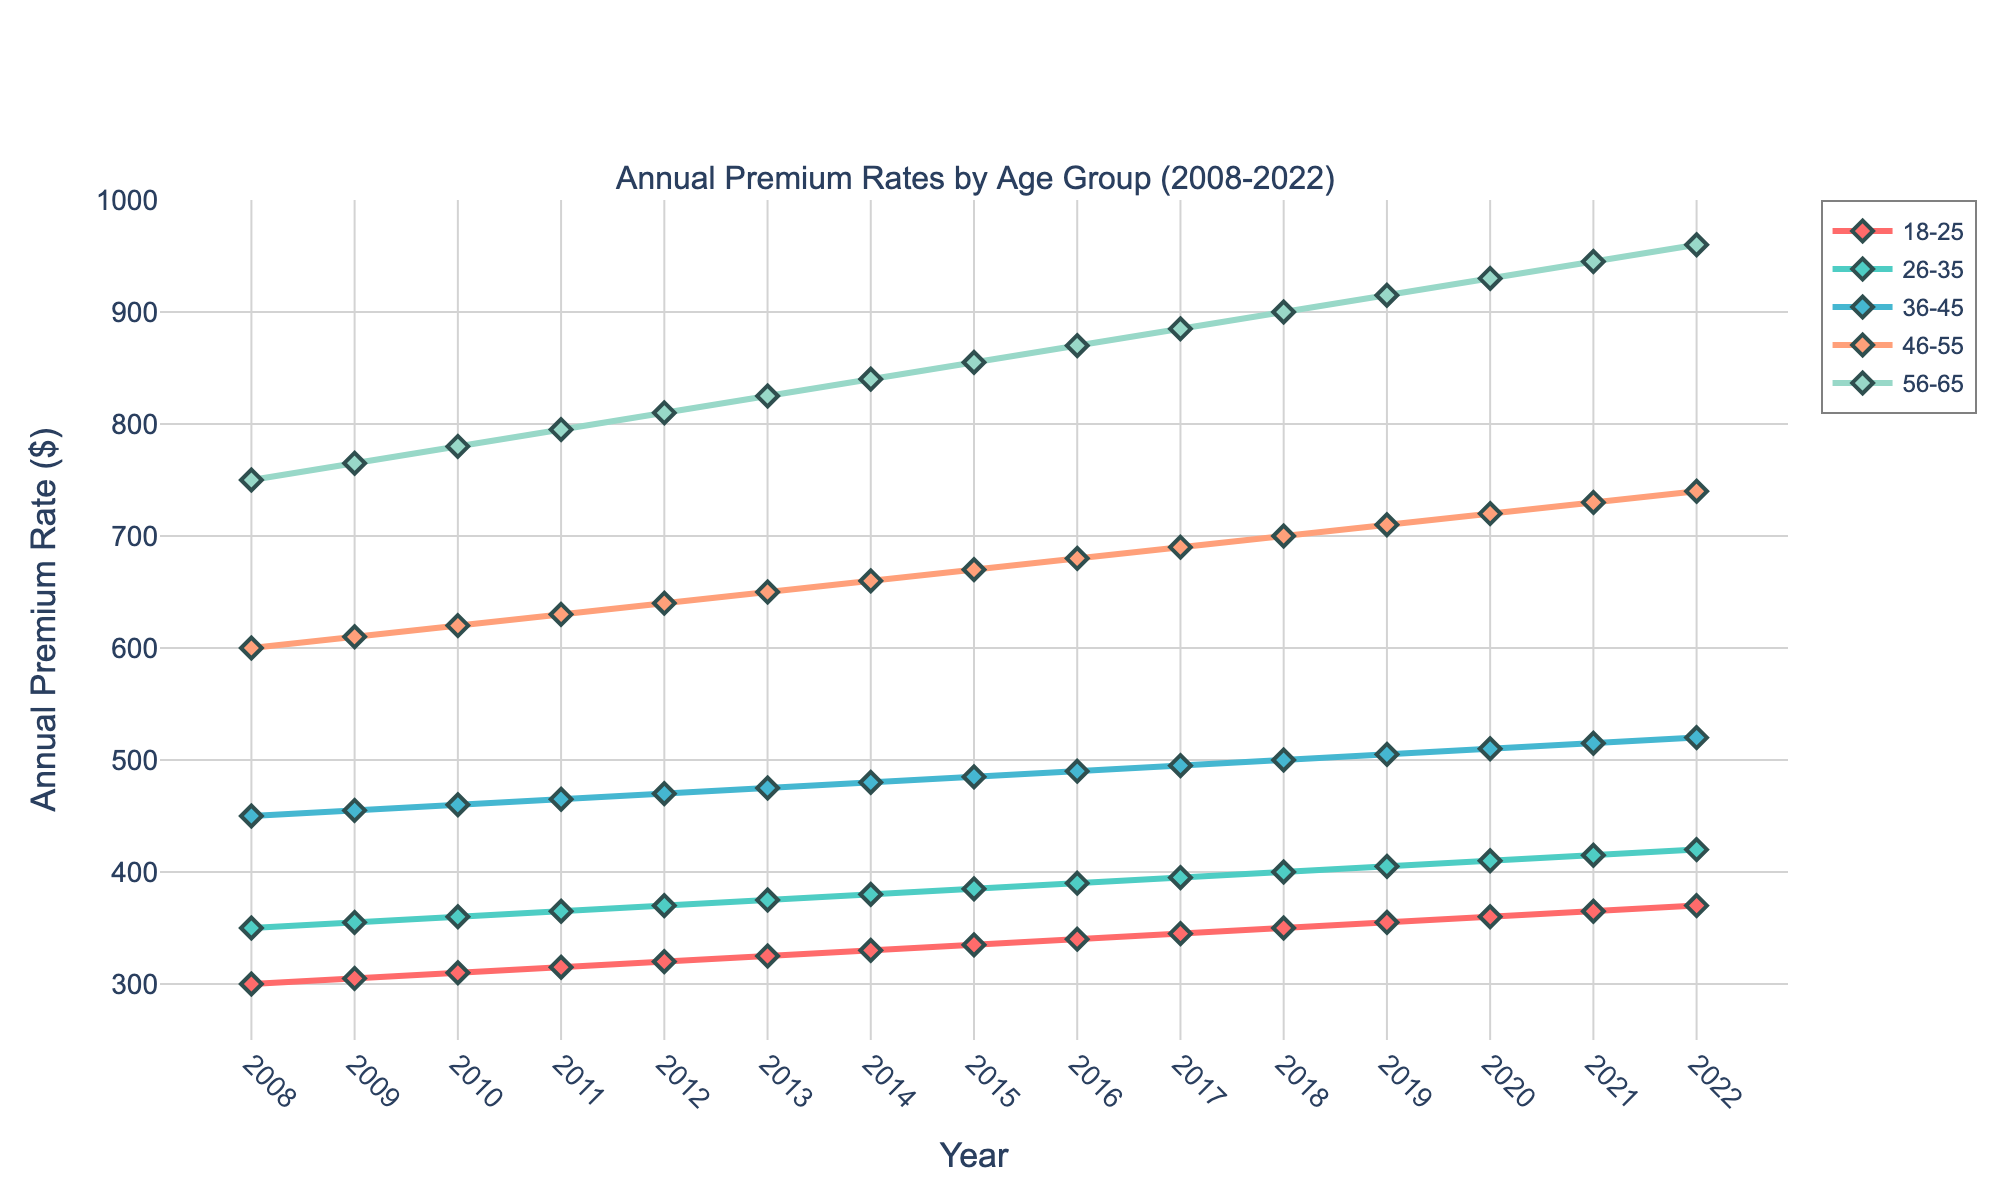What is the range of annual premium rates for the age group 36-45 in the year 2020? First, find the age group 36-45 in the year 2020 and check its annual premium rate, which is $510. The lowest annual premium rate for this age group over the 15 years is $450 (2008), and the highest is $520 (2022).
Answer: $510 How does the annual premium rate for the age group 18-25 change from 2008 to 2022? The annual premium rate for the age group 18-25 in 2008 is $300, and in 2022 it is $370. Compute the difference: $370 - $300 = $70.
Answer: Increased by $70 Which age group had the highest annual premium rate in 2022 and what was the rate? Look at the annual premium rates for all age groups in 2022. The age group 56-65 has the highest rate at $960.
Answer: Age group 56-65, $960 Between which years did the annual premium rate for the age group 46-55 see the largest increase? Examine the year-to-year changes in the rate for the age group 46-55: 
2008-2009 (+$10), 
2009-2010 (+$10), 
2010-2011 (+$10), 
2011-2012 (+$10), 
2012-2013 (+$10), 
2013-2014 (+$10), 
2014-2015 (+$10), 
2015-2016 (+$10), 
2016-2017 (+$10), 
2017-2018 (+$10), 
2018-2019 (+$10), 
2019-2020 (+$10), 
2020-2021 (+$10), 
2021-2022 (+$10). The largest increase occurred steadily each year with a consistent increase of $10.
Answer: Steadily each year with a $10 increase What is the average annual premium rate for the age group 26-35 throughout the 15 years? Sum the annual premium rates for the age group 26-35 from 2008 to 2022: 350 + 355 + 360 + 365 + 370 + 375 + 380 + 385 + 390 + 395 + 400 + 405 + 410 + 415 + 420 = 5900. Divide by 15 (number of years): 5900 / 15 = $393.33.
Answer: $393.33 Which year had the lowest annual premium rate for the age group 56-65, and what was the rate? Examine the annual premium rates for the age group 56-65 from 2008 to 2022. The lowest rate is $750 in 2008.
Answer: 2008, $750 Compare the trends in premium rates for the age groups 18-25 and 56-65 from 2008 to 2022. What do you observe? Both age groups show an increasing trend in their annual premium rates over the 15 years. However, the age group 56-65 had a higher starting value ($750 in 2008) and a higher ending value ($960 in 2022) compared to the age group 18-25 which started at $300 and ended at $370.
Answer: Both increase, but 56-65 has higher values throughout What is the total annual premium rate for all age groups combined in the year 2015? Sum the annual premium rates for all age groups in 2015: 335 + 385 + 485 + 670 + 855 = $2730.
Answer: $2730 Has there been any year where the annual premium rate for the age group 46-55 decreased compared to the previous year? Check the annual premium rates for the age group 46-55 from 2008 to 2022. All values increase sequentially each year; no decreases observed.
Answer: No For the age group 36-45, calculate the percentage increase in annual premium rates from 2008 to 2022. Determine the rate in 2008 ($450) and in 2022 ($520). Calculate the percentage increase: ((520 - 450) / 450) * 100 = 15.56%.
Answer: 15.56% 